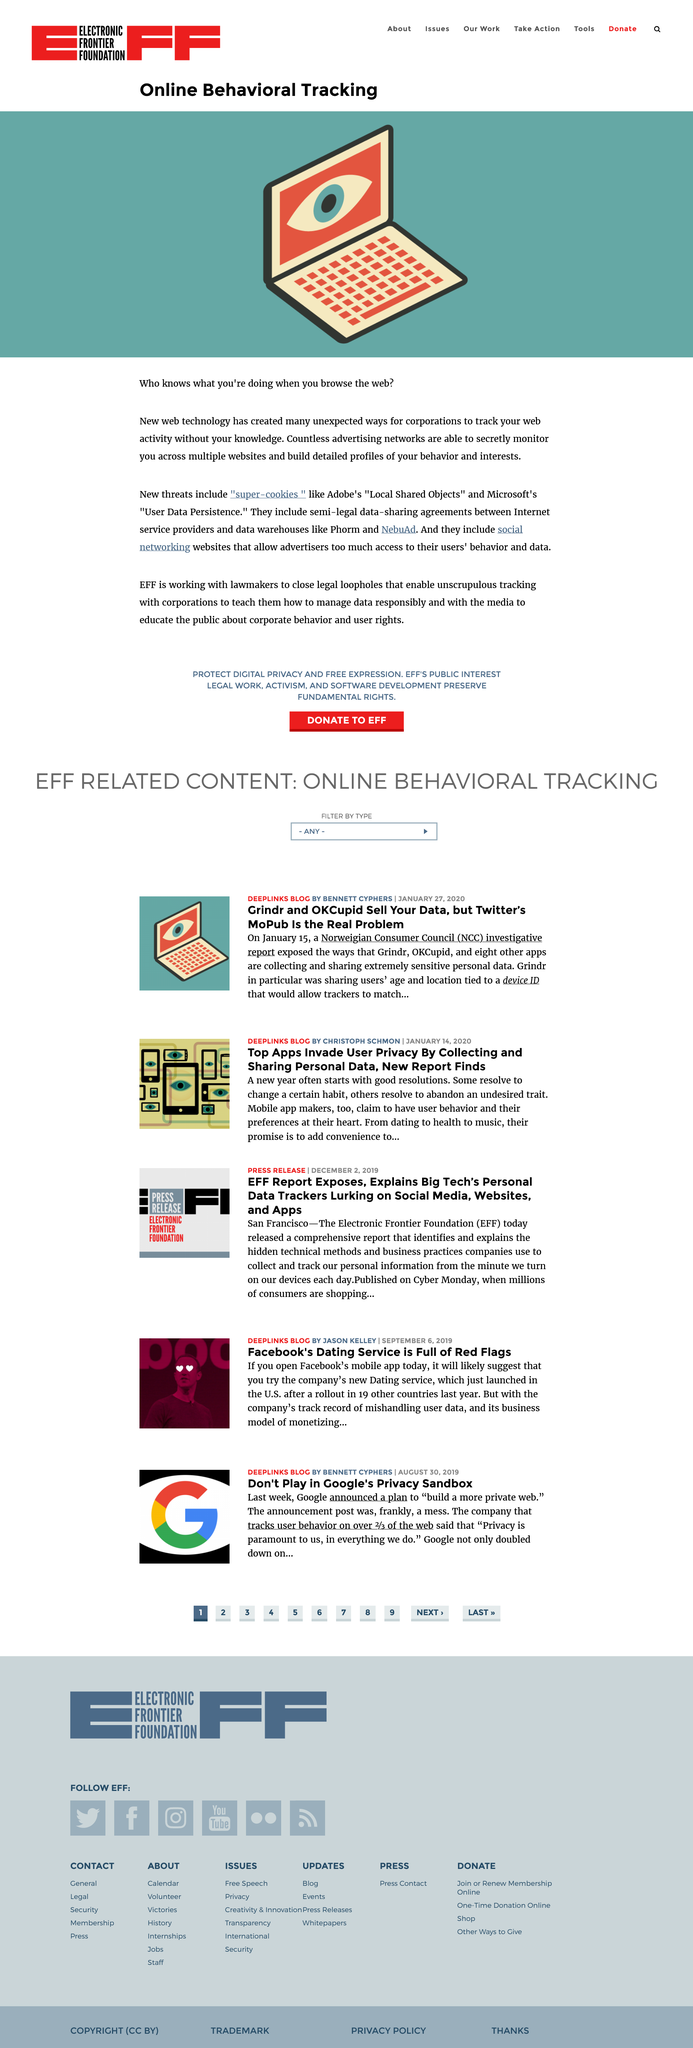Give some essential details in this illustration. Advertising networks collect information from users' browsing history and build detailed profiles of their behavior and interests by monitoring their website use. New threats to users' privacy while browsing the web include "super cookies," which are more persistent and harder to detect than traditional cookies. Advertising networks can secretly monitor your browsing activity across multiple websites. 